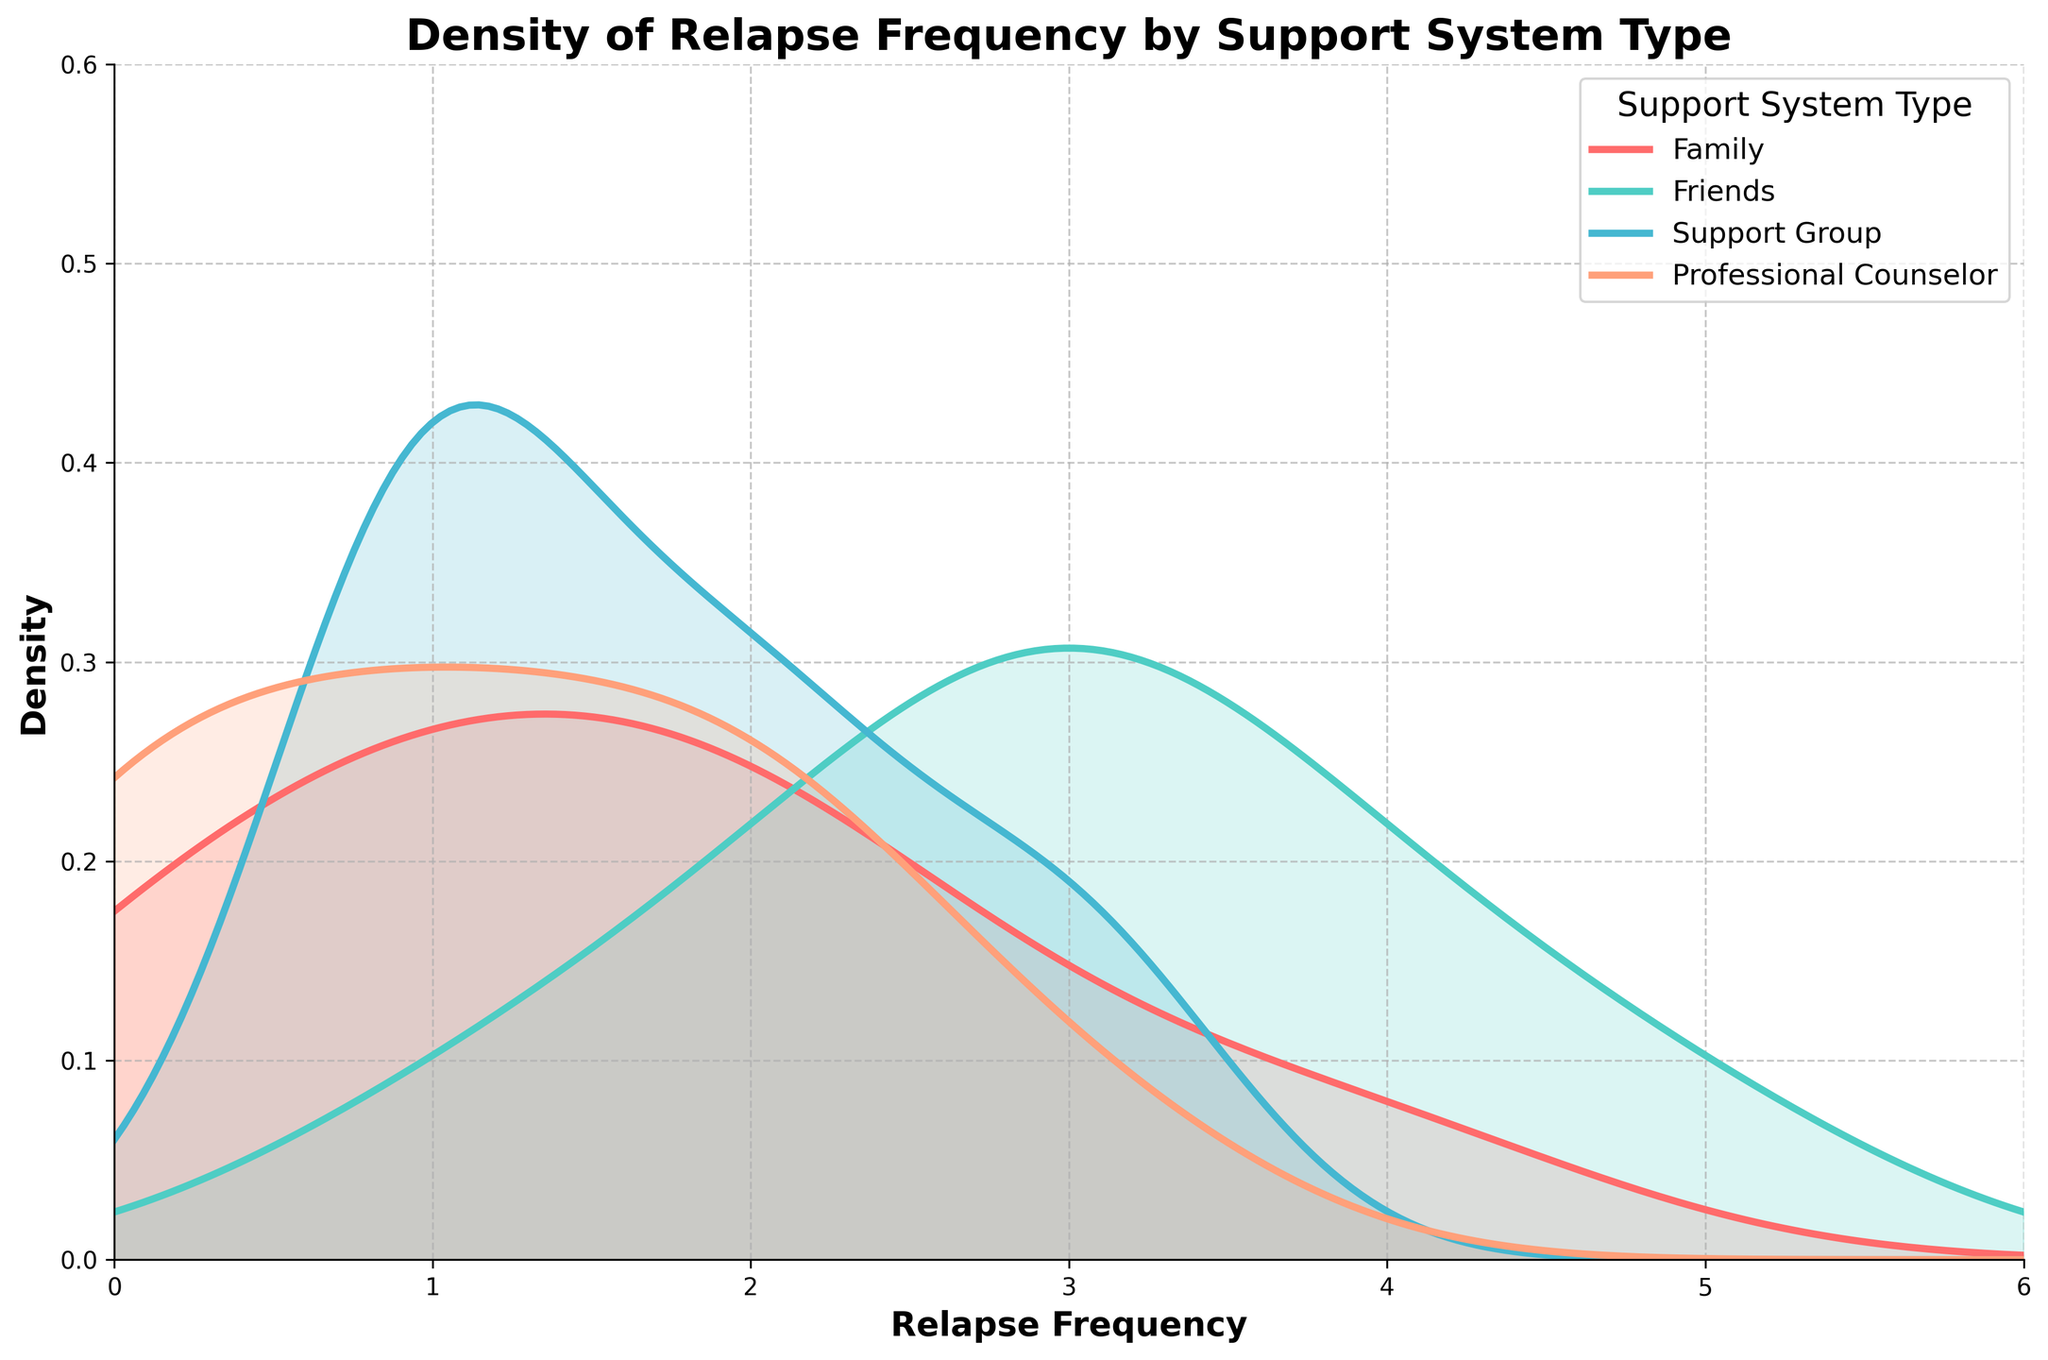What is the title of the figure? The title is usually displayed at the top of the figure. Here, it reads 'Density of Relapse Frequency by Support System Type.'
Answer: Density of Relapse Frequency by Support System Type Which support system type has the most frequent relapse events? From the graph, we can identify the peak density value for each support system. The 'Friends' support system shows a peak density at a relapse frequency of 3, which appears to be higher than other support systems.
Answer: Friends Which support system type has the lowest density at a relapse frequency of 0? The density values at relapse frequency of 0 for each support system can be visually compared. 'Friends' support system has the lowest density at that point.
Answer: Friends What is the peak density value for the Family support system? The peak density value can be observed at the highest point of the density curve for 'Family.' It appears around a relapse frequency of 1 or 2.
Answer: Around 2 Compare the density trends of 'Family' and 'Support Group' in terms of relapse frequency Both 'Family' and 'Support Group' curves have peaks, with 'Family' peaking earlier (around 1) and 'Support Group' peaking slightly later (between 1 and 2). The 'Support Group' sustains its density at a steady level thereafter.
Answer: Family peaks earlier, Support Group sustains density Which support system type shows more uniformly distributed relapse frequencies across the range? We look for the curve with a more evenly distributed density across frequencies. 'Professional Counselor' has a flatter curve compared to others, indicating more uniformly distributed relapse frequencies.
Answer: Professional Counselor Compare the sharpness of the peaks for 'Friends' and 'Support Group' The 'Friends' support system has a sharper peak indicating a more concentrated possibly higher frequency of relapse around 3. In contrast, 'Support Group' has a more spread-out peak across frequencies 1 and 2.
Answer: Friends has a sharper peak At relapse frequency of 2, which support system shows the highest density? By looking at the height of the density curves at relapse frequency 2, we see that 'Support Group' has the highest density compared to the other support systems.
Answer: Support Group What is the range of the X-axis in the figure? The X-axis is labeled "Relapse Frequency" and the plot ranges from 0 to 6, as indicated by the axis limits.
Answer: 0 to 6 Which two support systems have overlapping density curves at the higher end of relapse frequency (4-6)? Observing the curves from relapse frequency 4 to 6, both 'Friends' and 'Professional Counselor' show overlapping density trends in this range.
Answer: Friends and Professional Counselor 